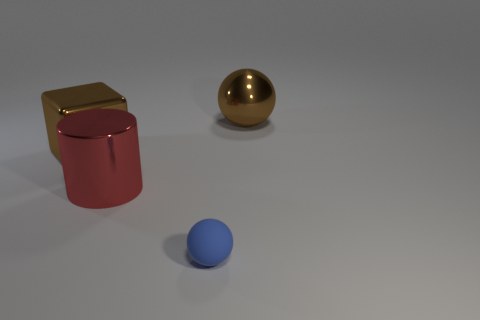Subtract all gray cubes. Subtract all green cylinders. How many cubes are left? 1 Add 3 big purple matte cylinders. How many objects exist? 7 Subtract all cubes. How many objects are left? 3 Add 2 tiny objects. How many tiny objects are left? 3 Add 1 blue matte things. How many blue matte things exist? 2 Subtract 0 purple cubes. How many objects are left? 4 Subtract all large brown metal things. Subtract all big cylinders. How many objects are left? 1 